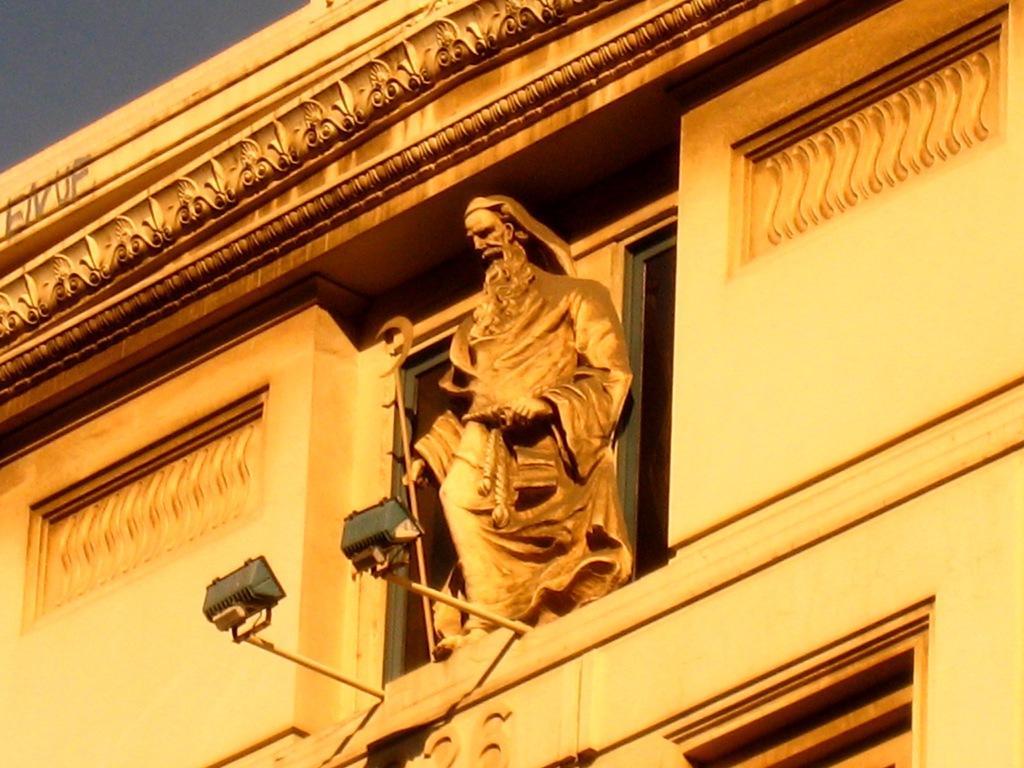Please provide a concise description of this image. In this image in the center there is a statue on the window of the building and there are lights in front of the statue and there is a building. 